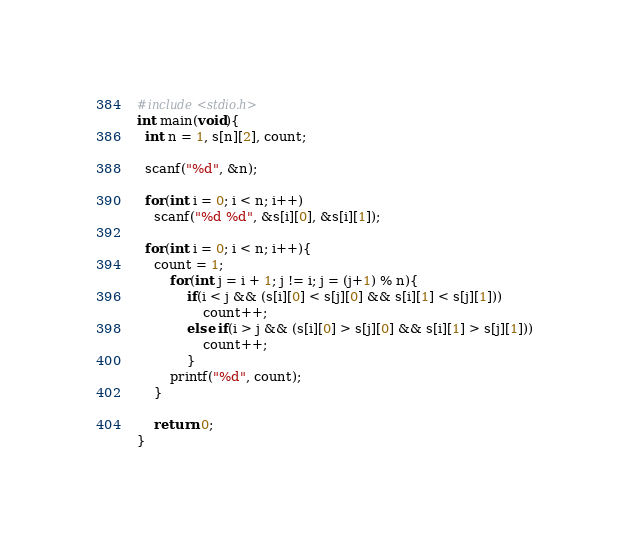Convert code to text. <code><loc_0><loc_0><loc_500><loc_500><_C_>#include<stdio.h>
int main(void){
  int n = 1, s[n][2], count;
  
  scanf("%d", &n);
  
  for(int i = 0; i < n; i++)
    scanf("%d %d", &s[i][0], &s[i][1]);
  
  for(int i = 0; i < n; i++){
    count = 1;
    	for(int j = i + 1; j != i; j = (j+1) % n){
    		if(i < j && (s[i][0] < s[j][0] && s[i][1] < s[j][1]))
       			count++;
    		else if(i > j && (s[i][0] > s[j][0] && s[i][1] > s[j][1]))
       			count++;
  			}
    	printf("%d", count);
    }
       
    return 0;
}
</code> 